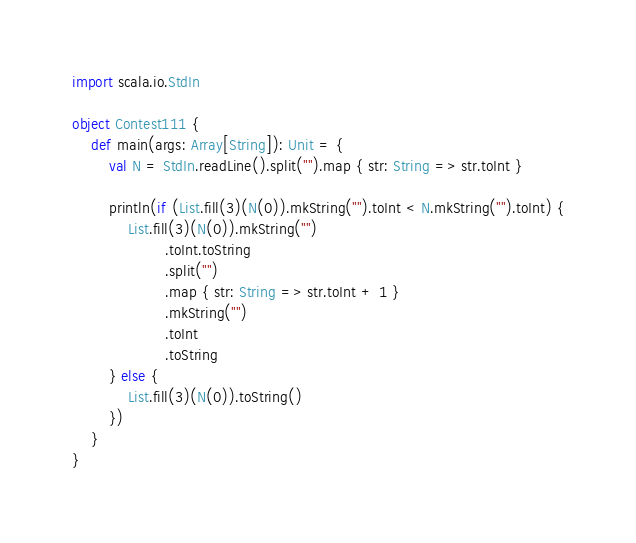<code> <loc_0><loc_0><loc_500><loc_500><_Scala_>import scala.io.StdIn

object Contest111 {
    def main(args: Array[String]): Unit = {
        val N = StdIn.readLine().split("").map { str: String => str.toInt }

        println(if (List.fill(3)(N(0)).mkString("").toInt < N.mkString("").toInt) {
            List.fill(3)(N(0)).mkString("")
                    .toInt.toString
                    .split("")
                    .map { str: String => str.toInt + 1 }
                    .mkString("")
                    .toInt
                    .toString
        } else {
            List.fill(3)(N(0)).toString()
        })
    }
}
</code> 